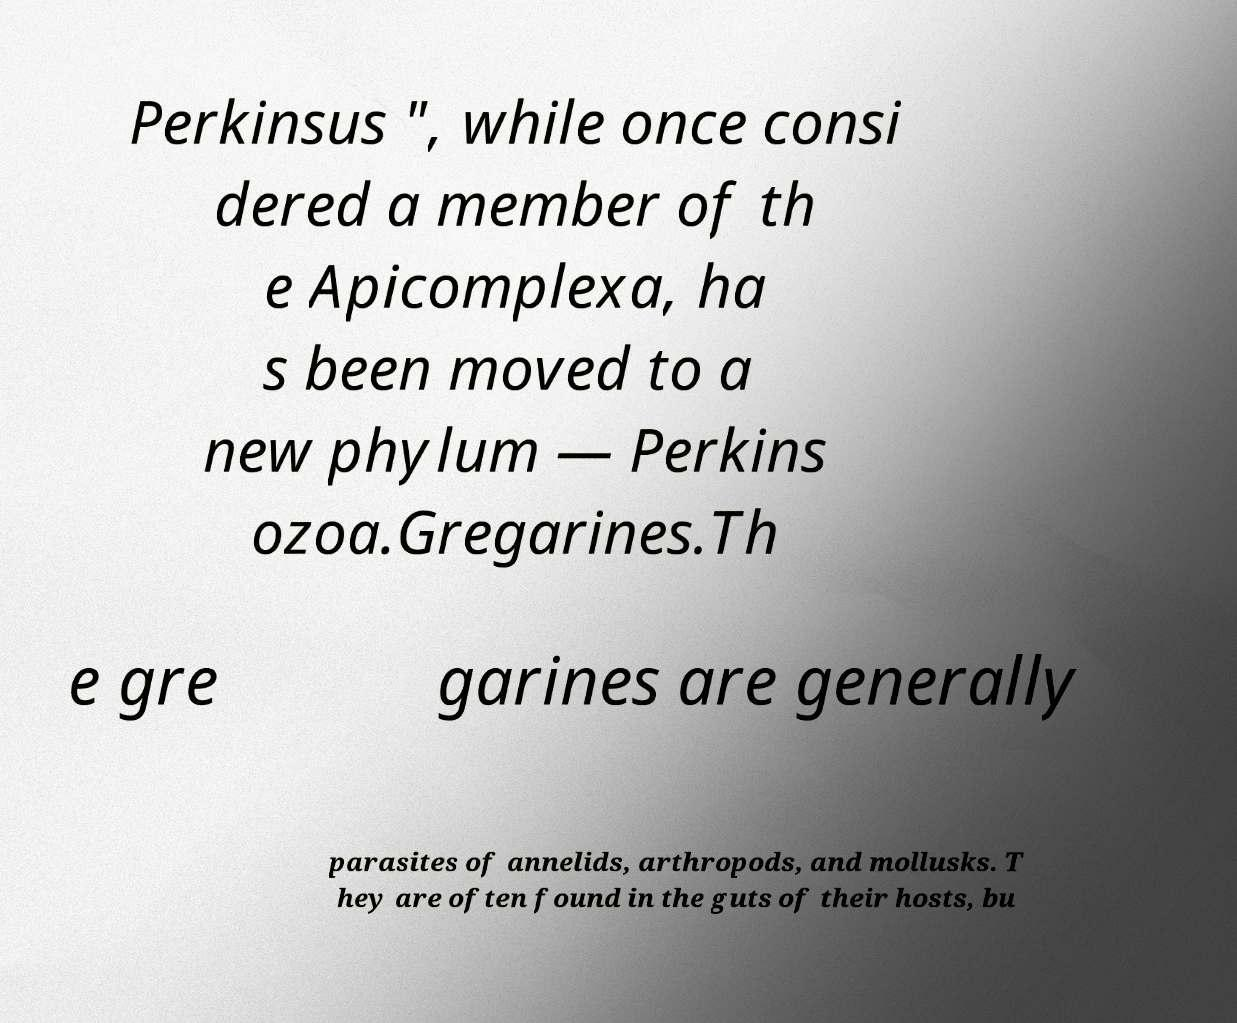For documentation purposes, I need the text within this image transcribed. Could you provide that? Perkinsus ", while once consi dered a member of th e Apicomplexa, ha s been moved to a new phylum — Perkins ozoa.Gregarines.Th e gre garines are generally parasites of annelids, arthropods, and mollusks. T hey are often found in the guts of their hosts, bu 